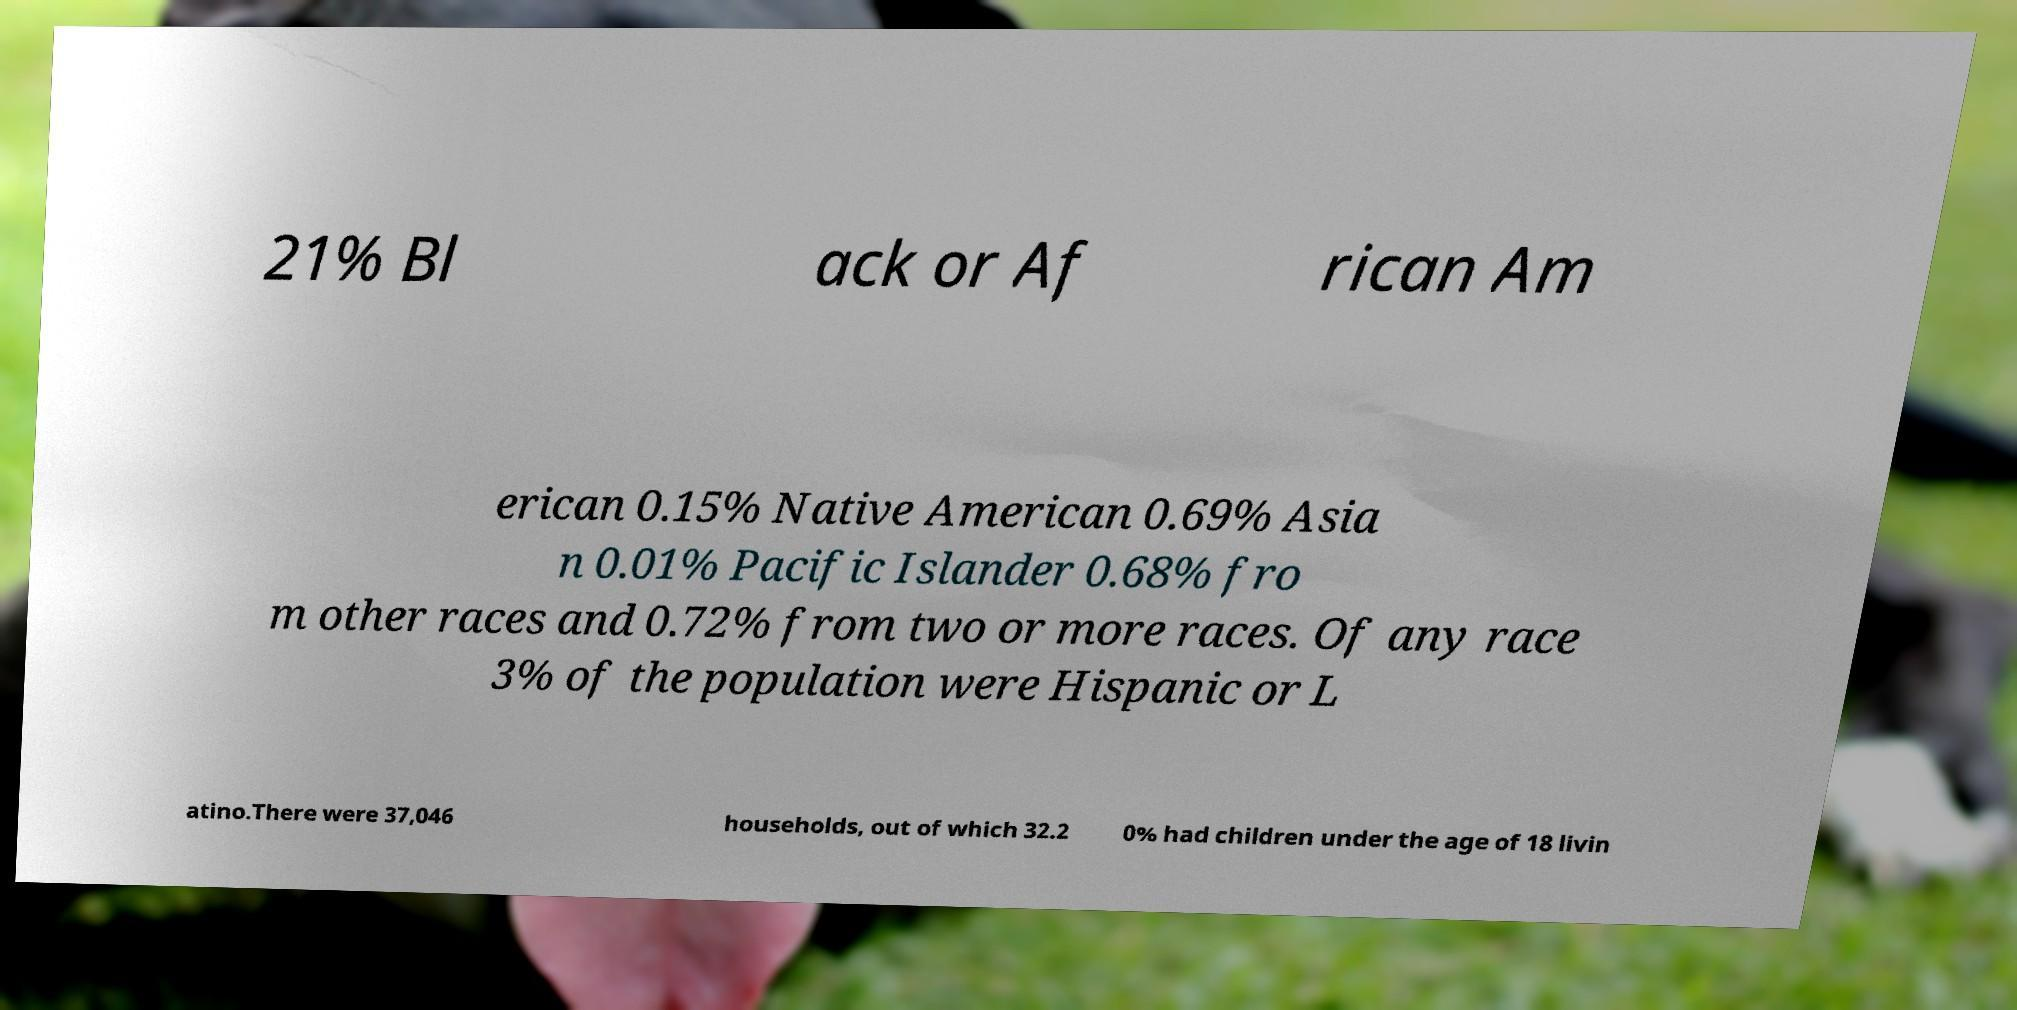Can you accurately transcribe the text from the provided image for me? 21% Bl ack or Af rican Am erican 0.15% Native American 0.69% Asia n 0.01% Pacific Islander 0.68% fro m other races and 0.72% from two or more races. Of any race 3% of the population were Hispanic or L atino.There were 37,046 households, out of which 32.2 0% had children under the age of 18 livin 